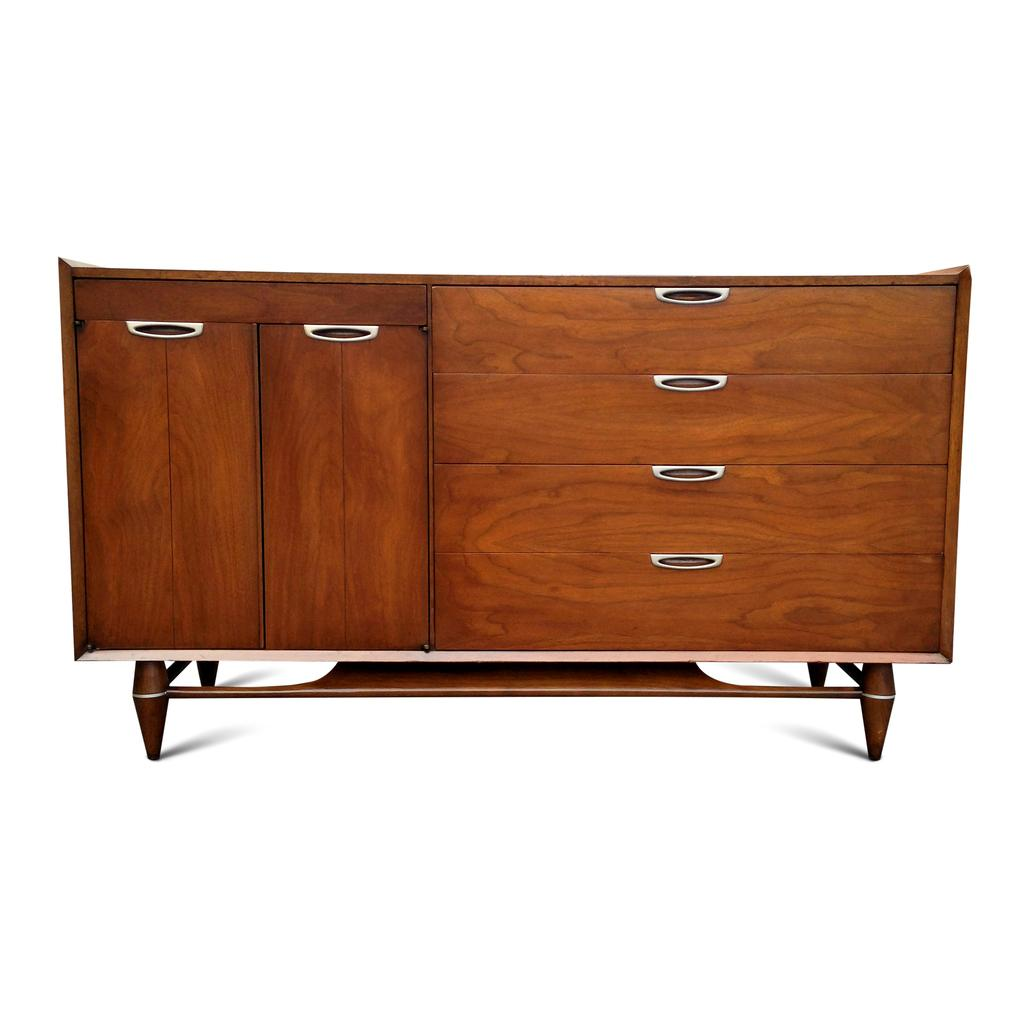What type of object is in the image? There is a wooden box in the image. Can you describe the material of the object? The object is made of wood. What might the wooden box be used for? The wooden box could be used for storage or as a decorative item. How many eyes does the wooden box have in the image? The wooden box does not have eyes, as it is an inanimate object. 